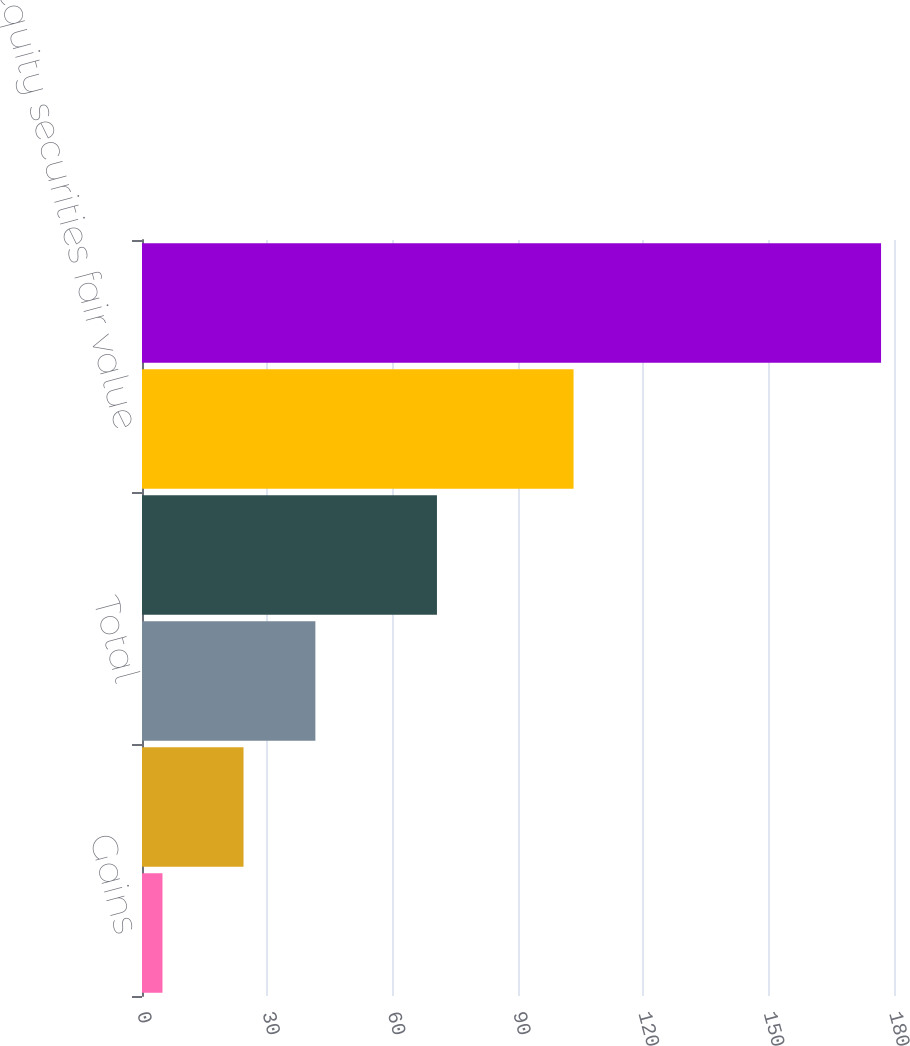Convert chart to OTSL. <chart><loc_0><loc_0><loc_500><loc_500><bar_chart><fcel>Gains<fcel>Losses<fcel>Total<fcel>Other-than-temporary<fcel>Equity securities fair value<fcel>Total net realized capital<nl><fcel>4.9<fcel>24.3<fcel>41.5<fcel>70.6<fcel>103.3<fcel>176.9<nl></chart> 